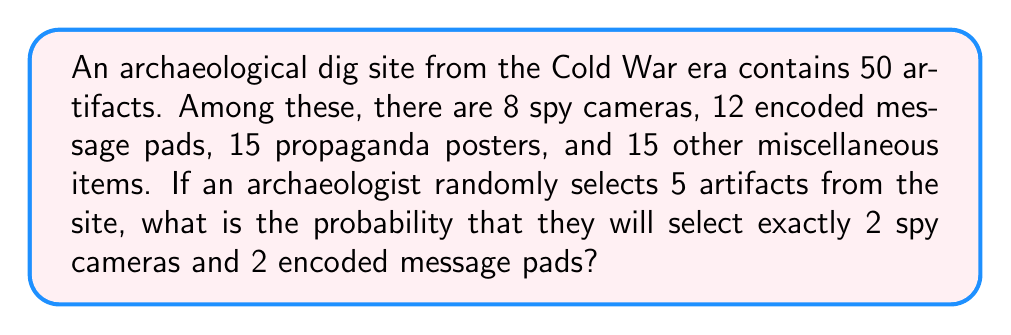Teach me how to tackle this problem. To solve this problem, we need to use the concept of hypergeometric distribution, which is applicable when sampling without replacement from a finite population.

Let's break down the problem step by step:

1. Total number of artifacts: 50
2. Number of spy cameras: 8
3. Number of encoded message pads: 12
4. Number of artifacts to be selected: 5
5. We want exactly 2 spy cameras and 2 encoded message pads

The probability can be calculated using the following formula:

$$ P(X = k) = \frac{\binom{K}{k} \binom{N-K}{n-k}}{\binom{N}{n}} $$

Where:
- $N$ is the total population size (50 artifacts)
- $K$ is the number of success states in the population (8 spy cameras for the first part, 12 encoded message pads for the second part)
- $n$ is the number of draws (5 artifacts selected)
- $k$ is the number of observed successes (2 for each part)

We need to calculate this probability for both spy cameras and encoded message pads, then multiply them together and multiply by the number of ways to choose the last artifact.

For spy cameras:
$$ P(\text{2 spy cameras}) = \frac{\binom{8}{2} \binom{50-8}{5-2}}{\binom{50}{5}} $$

For encoded message pads:
$$ P(\text{2 encoded message pads}) = \frac{\binom{12}{2} \binom{50-12}{5-2}}{\binom{50}{5}} $$

The probability of selecting the last artifact from the remaining items:
$$ P(\text{1 other item}) = \frac{30}{46} $$

Now, let's calculate:

1. $\binom{8}{2} = 28$
2. $\binom{42}{3} = 11480$
3. $\binom{50}{5} = 2118760$
4. $\binom{12}{2} = 66$
5. $\binom{38}{3} = 8436$

Putting it all together:

$$ P(\text{2 spy cameras and 2 encoded message pads}) = \frac{28 \cdot 11480}{2118760} \cdot \frac{66 \cdot 8436}{2118760} \cdot \frac{30}{46} $$

$$ = 0.1516 \cdot 0.2632 \cdot 0.6522 = 0.0260 $$

Therefore, the probability is approximately 0.0260 or 2.60%.
Answer: 0.0260 or 2.60% 